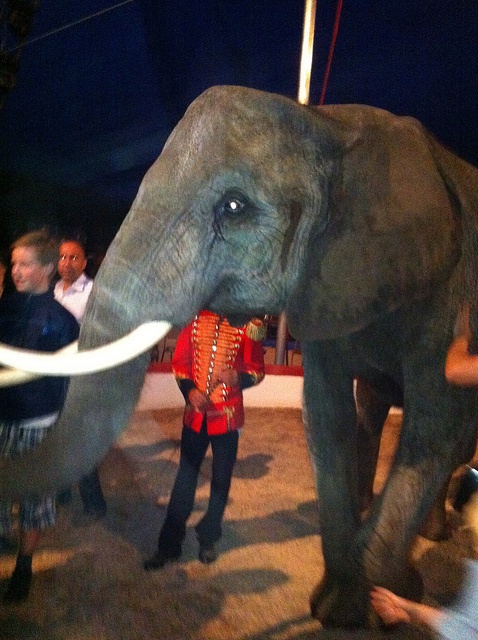Describe the objects in this image and their specific colors. I can see elephant in black, gray, and maroon tones, people in black, brown, maroon, and red tones, people in black, gray, maroon, and brown tones, people in black, darkgray, maroon, brown, and gray tones, and people in black, lightgray, maroon, and brown tones in this image. 